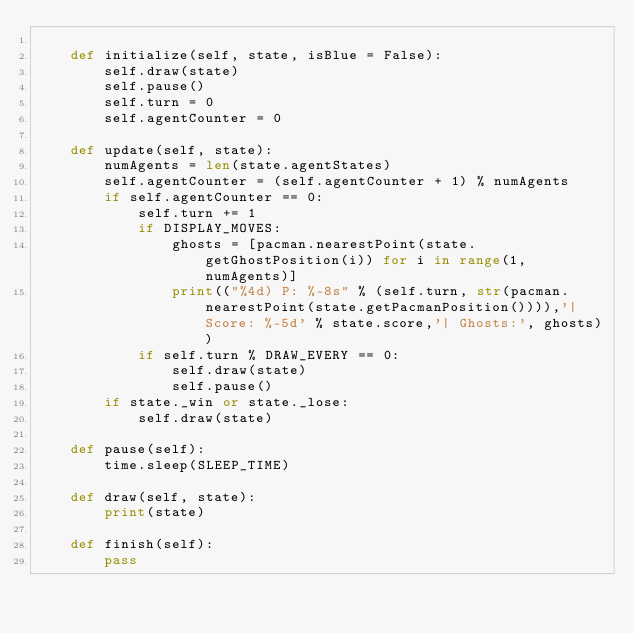<code> <loc_0><loc_0><loc_500><loc_500><_Python_>
    def initialize(self, state, isBlue = False):
        self.draw(state)
        self.pause()
        self.turn = 0
        self.agentCounter = 0

    def update(self, state):
        numAgents = len(state.agentStates)
        self.agentCounter = (self.agentCounter + 1) % numAgents
        if self.agentCounter == 0:
            self.turn += 1
            if DISPLAY_MOVES:
                ghosts = [pacman.nearestPoint(state.getGhostPosition(i)) for i in range(1, numAgents)]
                print(("%4d) P: %-8s" % (self.turn, str(pacman.nearestPoint(state.getPacmanPosition()))),'| Score: %-5d' % state.score,'| Ghosts:', ghosts))
            if self.turn % DRAW_EVERY == 0:
                self.draw(state)
                self.pause()
        if state._win or state._lose:
            self.draw(state)

    def pause(self):
        time.sleep(SLEEP_TIME)

    def draw(self, state):
        print(state)

    def finish(self):
        pass
</code> 